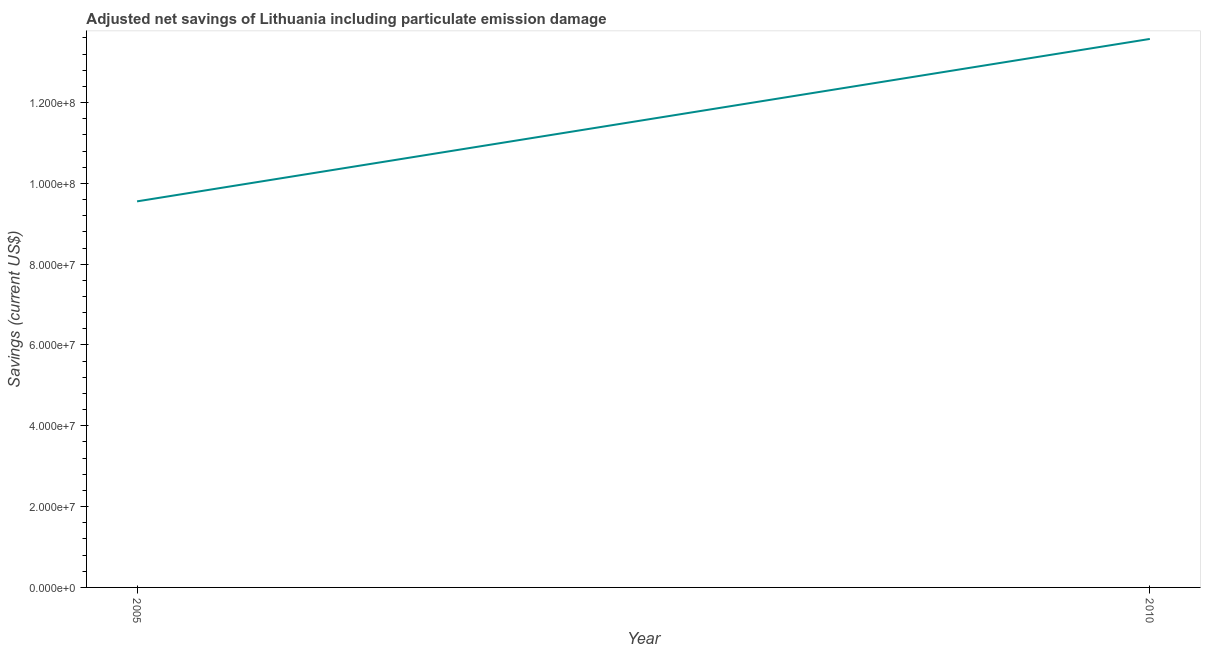What is the adjusted net savings in 2005?
Make the answer very short. 9.55e+07. Across all years, what is the maximum adjusted net savings?
Your answer should be very brief. 1.36e+08. Across all years, what is the minimum adjusted net savings?
Give a very brief answer. 9.55e+07. In which year was the adjusted net savings maximum?
Your answer should be very brief. 2010. What is the sum of the adjusted net savings?
Offer a terse response. 2.31e+08. What is the difference between the adjusted net savings in 2005 and 2010?
Your response must be concise. -4.02e+07. What is the average adjusted net savings per year?
Give a very brief answer. 1.16e+08. What is the median adjusted net savings?
Ensure brevity in your answer.  1.16e+08. In how many years, is the adjusted net savings greater than 48000000 US$?
Offer a very short reply. 2. Do a majority of the years between 2010 and 2005 (inclusive) have adjusted net savings greater than 64000000 US$?
Offer a very short reply. No. What is the ratio of the adjusted net savings in 2005 to that in 2010?
Your answer should be compact. 0.7. Is the adjusted net savings in 2005 less than that in 2010?
Your response must be concise. Yes. In how many years, is the adjusted net savings greater than the average adjusted net savings taken over all years?
Your response must be concise. 1. Does the adjusted net savings monotonically increase over the years?
Make the answer very short. Yes. How many lines are there?
Make the answer very short. 1. What is the difference between two consecutive major ticks on the Y-axis?
Offer a very short reply. 2.00e+07. Are the values on the major ticks of Y-axis written in scientific E-notation?
Offer a terse response. Yes. Does the graph contain any zero values?
Offer a very short reply. No. What is the title of the graph?
Keep it short and to the point. Adjusted net savings of Lithuania including particulate emission damage. What is the label or title of the X-axis?
Make the answer very short. Year. What is the label or title of the Y-axis?
Provide a short and direct response. Savings (current US$). What is the Savings (current US$) in 2005?
Your response must be concise. 9.55e+07. What is the Savings (current US$) of 2010?
Keep it short and to the point. 1.36e+08. What is the difference between the Savings (current US$) in 2005 and 2010?
Provide a succinct answer. -4.02e+07. What is the ratio of the Savings (current US$) in 2005 to that in 2010?
Your response must be concise. 0.7. 